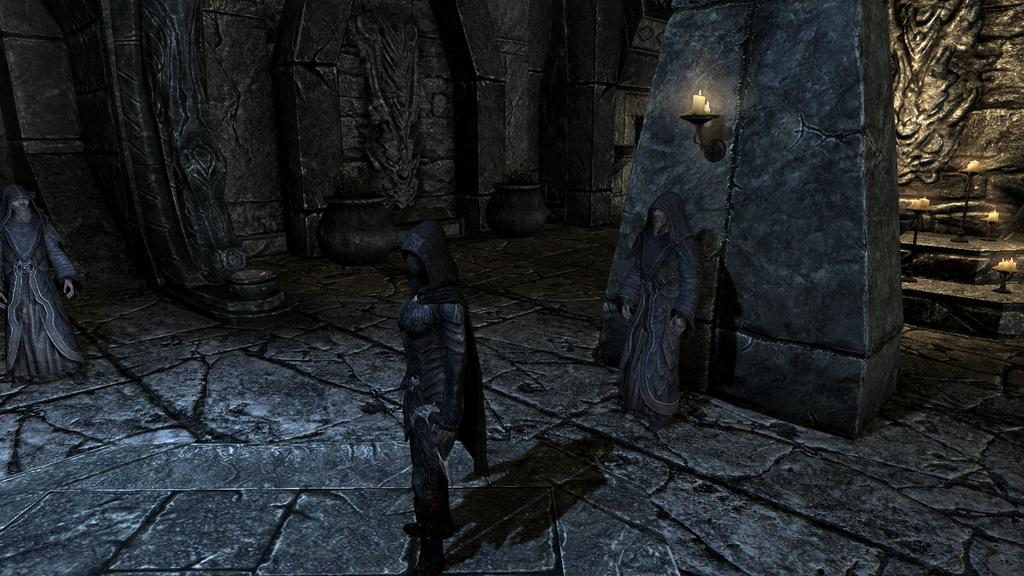What type of image is being described? The image is an animation. Can you describe the characters in the image? There are people in the image. What can be seen in the background of the image? There are walls in the background of the image. What objects are present in the image that provide light? Candles are placed on holders in the image. Where is the library located in the image? There is no library present in the image. What type of church can be seen in the background of the image? There is no church present in the image. 